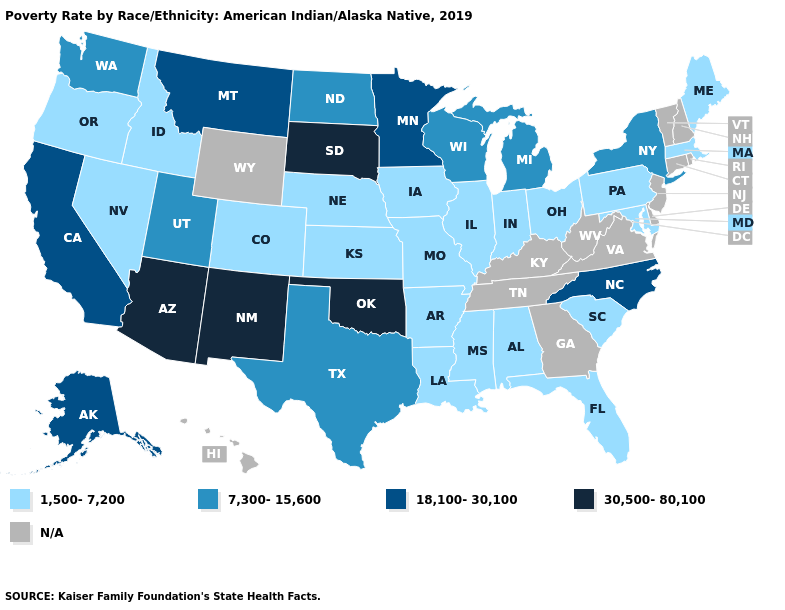What is the value of Alaska?
Give a very brief answer. 18,100-30,100. What is the value of Utah?
Short answer required. 7,300-15,600. What is the value of Washington?
Give a very brief answer. 7,300-15,600. Is the legend a continuous bar?
Quick response, please. No. What is the value of Iowa?
Be succinct. 1,500-7,200. What is the highest value in the USA?
Be succinct. 30,500-80,100. Name the states that have a value in the range 18,100-30,100?
Answer briefly. Alaska, California, Minnesota, Montana, North Carolina. What is the value of Alabama?
Keep it brief. 1,500-7,200. Does Alaska have the lowest value in the USA?
Answer briefly. No. Which states have the highest value in the USA?
Answer briefly. Arizona, New Mexico, Oklahoma, South Dakota. Name the states that have a value in the range 30,500-80,100?
Answer briefly. Arizona, New Mexico, Oklahoma, South Dakota. Name the states that have a value in the range N/A?
Keep it brief. Connecticut, Delaware, Georgia, Hawaii, Kentucky, New Hampshire, New Jersey, Rhode Island, Tennessee, Vermont, Virginia, West Virginia, Wyoming. What is the lowest value in the MidWest?
Be succinct. 1,500-7,200. 